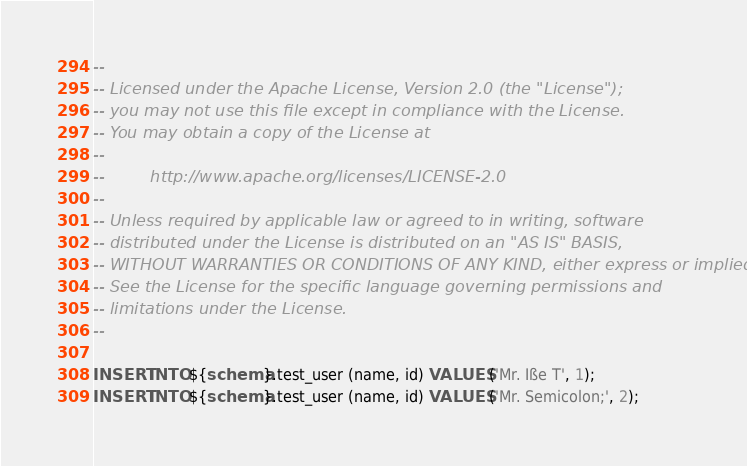<code> <loc_0><loc_0><loc_500><loc_500><_SQL_>--
-- Licensed under the Apache License, Version 2.0 (the "License");
-- you may not use this file except in compliance with the License.
-- You may obtain a copy of the License at
--
--         http://www.apache.org/licenses/LICENSE-2.0
--
-- Unless required by applicable law or agreed to in writing, software
-- distributed under the License is distributed on an "AS IS" BASIS,
-- WITHOUT WARRANTIES OR CONDITIONS OF ANY KIND, either express or implied.
-- See the License for the specific language governing permissions and
-- limitations under the License.
--

INSERT INTO ${schema}.test_user (name, id) VALUES ('Mr. Iße T', 1);
INSERT INTO ${schema}.test_user (name, id) VALUES ('Mr. Semicolon;', 2);</code> 